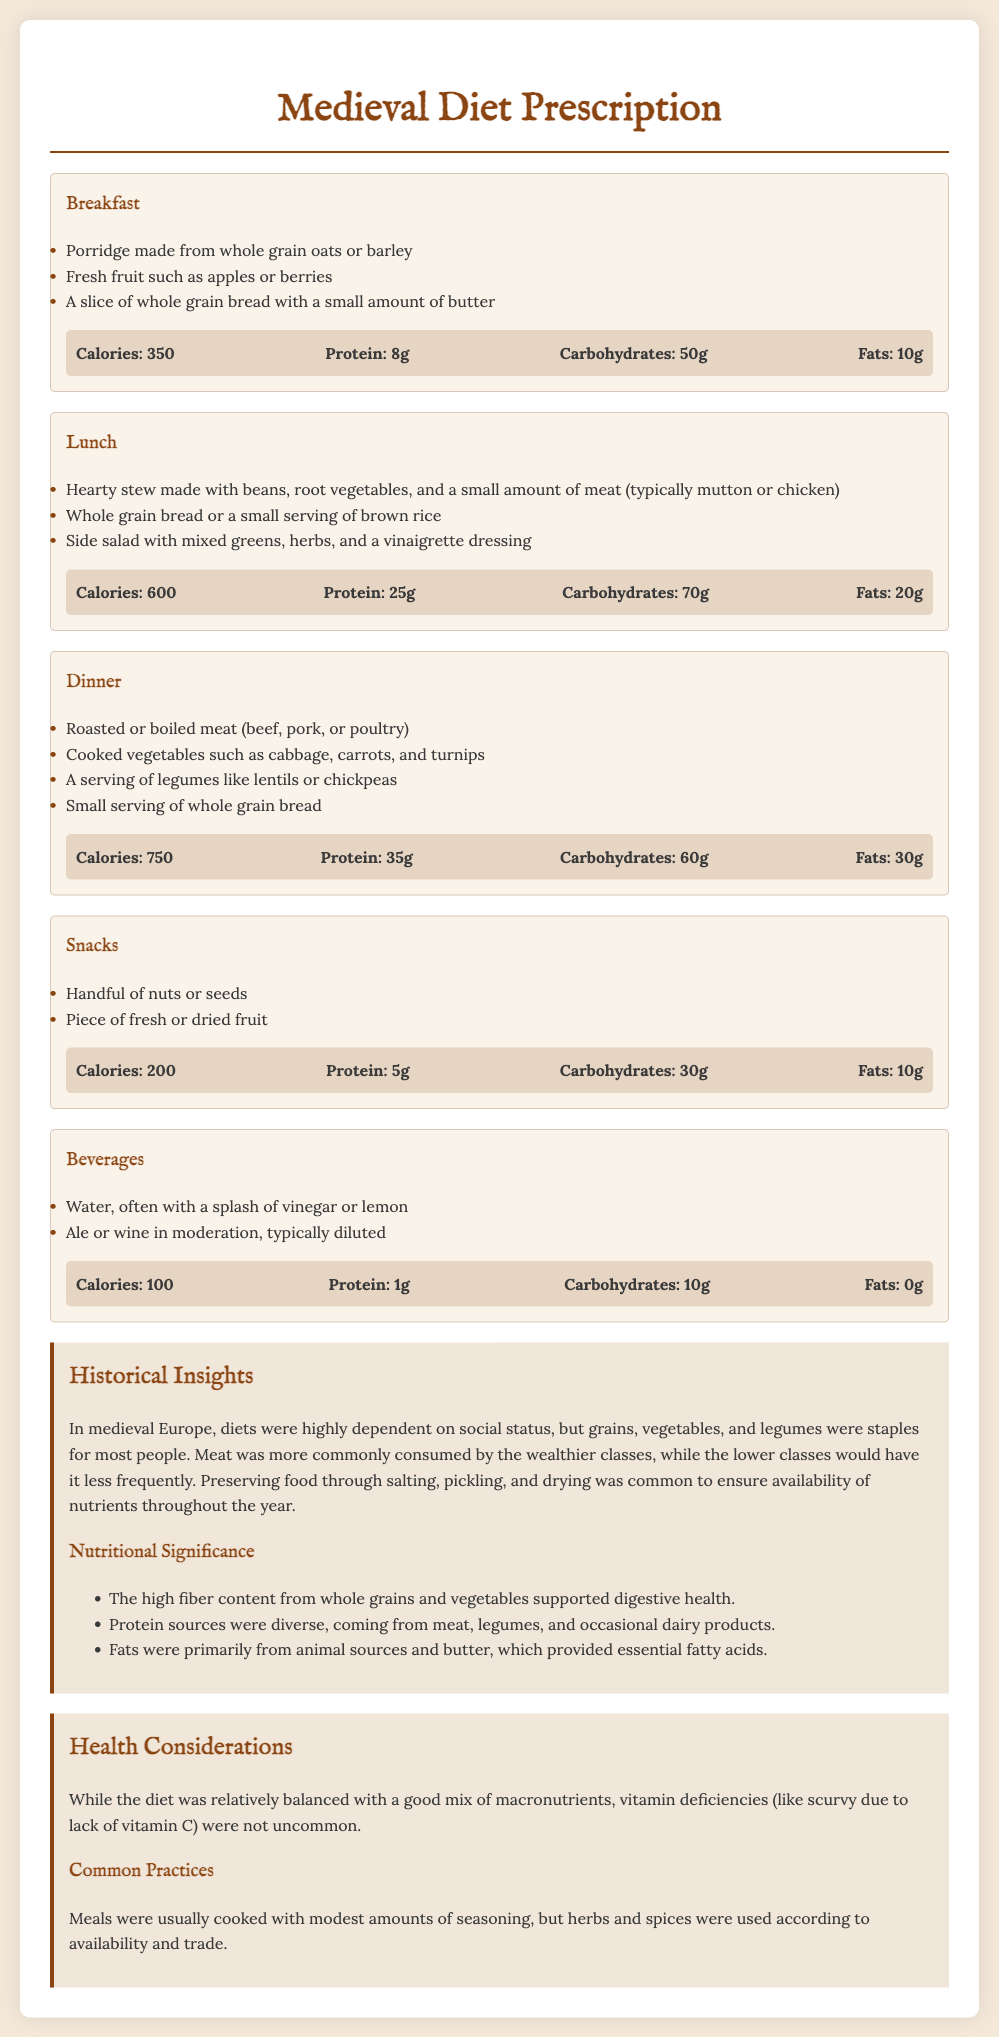what are the breakfast items? The breakfast items include porridge made from whole grain oats or barley, fresh fruit such as apples or berries, and a slice of whole grain bread with a small amount of butter.
Answer: porridge made from whole grain oats or barley, fresh fruit such as apples or berries, a slice of whole grain bread with a small amount of butter how many grams of protein are in lunch? The protein content for lunch is stated in the nutritional information section, which indicates 25 grams.
Answer: 25g what type of meat is commonly used in the hearty stew? The document mentions that the hearty stew is typically made with a small amount of meat such as mutton or chicken.
Answer: mutton or chicken what is the calorie count for dinner? The calorie count for dinner is specified in the nutritional information as 750 calories.
Answer: 750 what was a common practice for preserving food? The document notes that preserving food through salting, pickling, and drying was common.
Answer: salting, pickling, and drying what is the significance of high fiber content? The document states that high fiber content from whole grains and vegetables supported digestive health.
Answer: digestive health how often did lower classes consume meat? The document explains that lower classes would consume meat less frequently.
Answer: less frequently what was a common vitamin deficiency mentioned? The document states that vitamin deficiencies like scurvy due to lack of vitamin C were not uncommon.
Answer: scurvy 